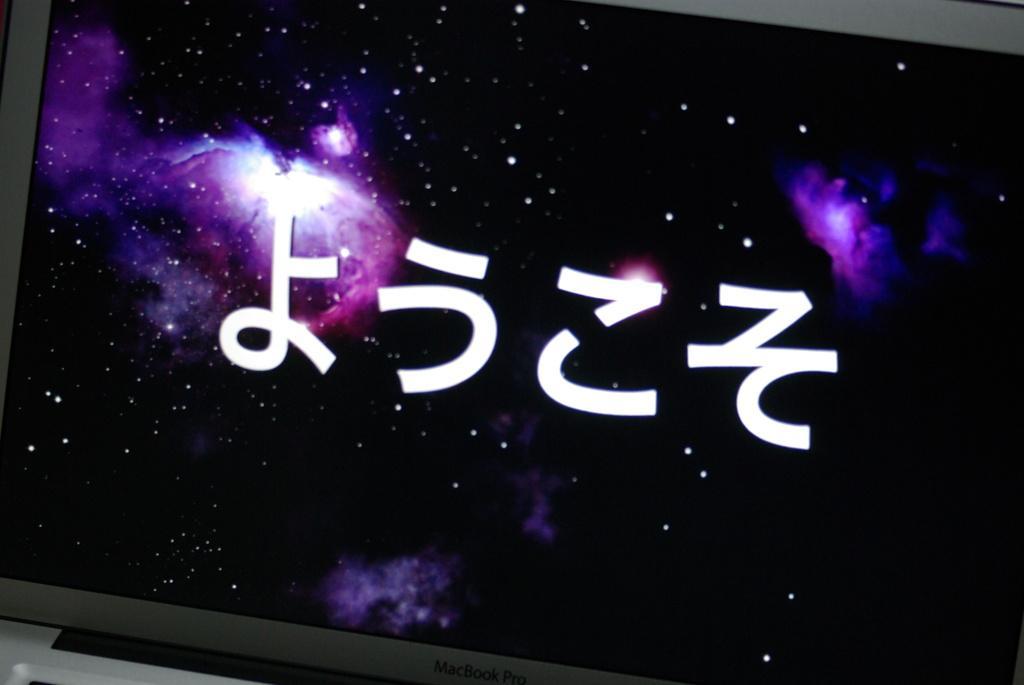Please provide a concise description of this image. It is the screen of a desktop and some text is displayed on the screen. 